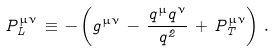<formula> <loc_0><loc_0><loc_500><loc_500>P _ { L } ^ { \mu \nu } \, \equiv \, - \left ( g ^ { \mu \nu } \, - \, \frac { q ^ { \mu } q ^ { \nu } } { q ^ { 2 } } \, + \, P _ { T } ^ { \mu \nu } \right ) \, .</formula> 